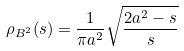<formula> <loc_0><loc_0><loc_500><loc_500>\rho _ { B ^ { 2 } } ( s ) = \frac { 1 } { \pi a ^ { 2 } } \sqrt { \frac { 2 a ^ { 2 } - s } { s } }</formula> 